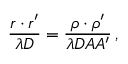<formula> <loc_0><loc_0><loc_500><loc_500>{ \frac { \boldsymbol r \boldsymbol \cdot \boldsymbol r ^ { \prime } } { \lambda D } } = { \frac { \boldsymbol \rho \boldsymbol \cdot \boldsymbol \rho ^ { \prime } } { \lambda D A A ^ { \prime } } } \, ,</formula> 